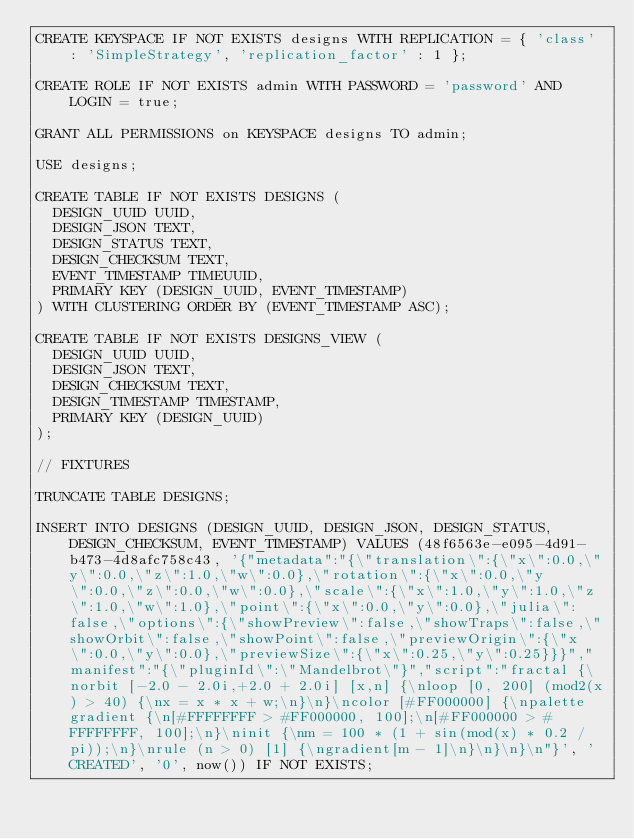Convert code to text. <code><loc_0><loc_0><loc_500><loc_500><_SQL_>CREATE KEYSPACE IF NOT EXISTS designs WITH REPLICATION = { 'class' : 'SimpleStrategy', 'replication_factor' : 1 };

CREATE ROLE IF NOT EXISTS admin WITH PASSWORD = 'password' AND LOGIN = true;

GRANT ALL PERMISSIONS on KEYSPACE designs TO admin;

USE designs;

CREATE TABLE IF NOT EXISTS DESIGNS (
  DESIGN_UUID UUID,
  DESIGN_JSON TEXT,
  DESIGN_STATUS TEXT,
  DESIGN_CHECKSUM TEXT,
  EVENT_TIMESTAMP TIMEUUID,
  PRIMARY KEY (DESIGN_UUID, EVENT_TIMESTAMP)
) WITH CLUSTERING ORDER BY (EVENT_TIMESTAMP ASC);

CREATE TABLE IF NOT EXISTS DESIGNS_VIEW (
  DESIGN_UUID UUID,
  DESIGN_JSON TEXT,
  DESIGN_CHECKSUM TEXT,
  DESIGN_TIMESTAMP TIMESTAMP,
  PRIMARY KEY (DESIGN_UUID)
);

// FIXTURES

TRUNCATE TABLE DESIGNS;

INSERT INTO DESIGNS (DESIGN_UUID, DESIGN_JSON, DESIGN_STATUS, DESIGN_CHECKSUM, EVENT_TIMESTAMP) VALUES (48f6563e-e095-4d91-b473-4d8afc758c43, '{"metadata":"{\"translation\":{\"x\":0.0,\"y\":0.0,\"z\":1.0,\"w\":0.0},\"rotation\":{\"x\":0.0,\"y\":0.0,\"z\":0.0,\"w\":0.0},\"scale\":{\"x\":1.0,\"y\":1.0,\"z\":1.0,\"w\":1.0},\"point\":{\"x\":0.0,\"y\":0.0},\"julia\":false,\"options\":{\"showPreview\":false,\"showTraps\":false,\"showOrbit\":false,\"showPoint\":false,\"previewOrigin\":{\"x\":0.0,\"y\":0.0},\"previewSize\":{\"x\":0.25,\"y\":0.25}}}","manifest":"{\"pluginId\":\"Mandelbrot\"}","script":"fractal {\norbit [-2.0 - 2.0i,+2.0 + 2.0i] [x,n] {\nloop [0, 200] (mod2(x) > 40) {\nx = x * x + w;\n}\n}\ncolor [#FF000000] {\npalette gradient {\n[#FFFFFFFF > #FF000000, 100];\n[#FF000000 > #FFFFFFFF, 100];\n}\ninit {\nm = 100 * (1 + sin(mod(x) * 0.2 / pi));\n}\nrule (n > 0) [1] {\ngradient[m - 1]\n}\n}\n}\n"}', 'CREATED', '0', now()) IF NOT EXISTS;
</code> 